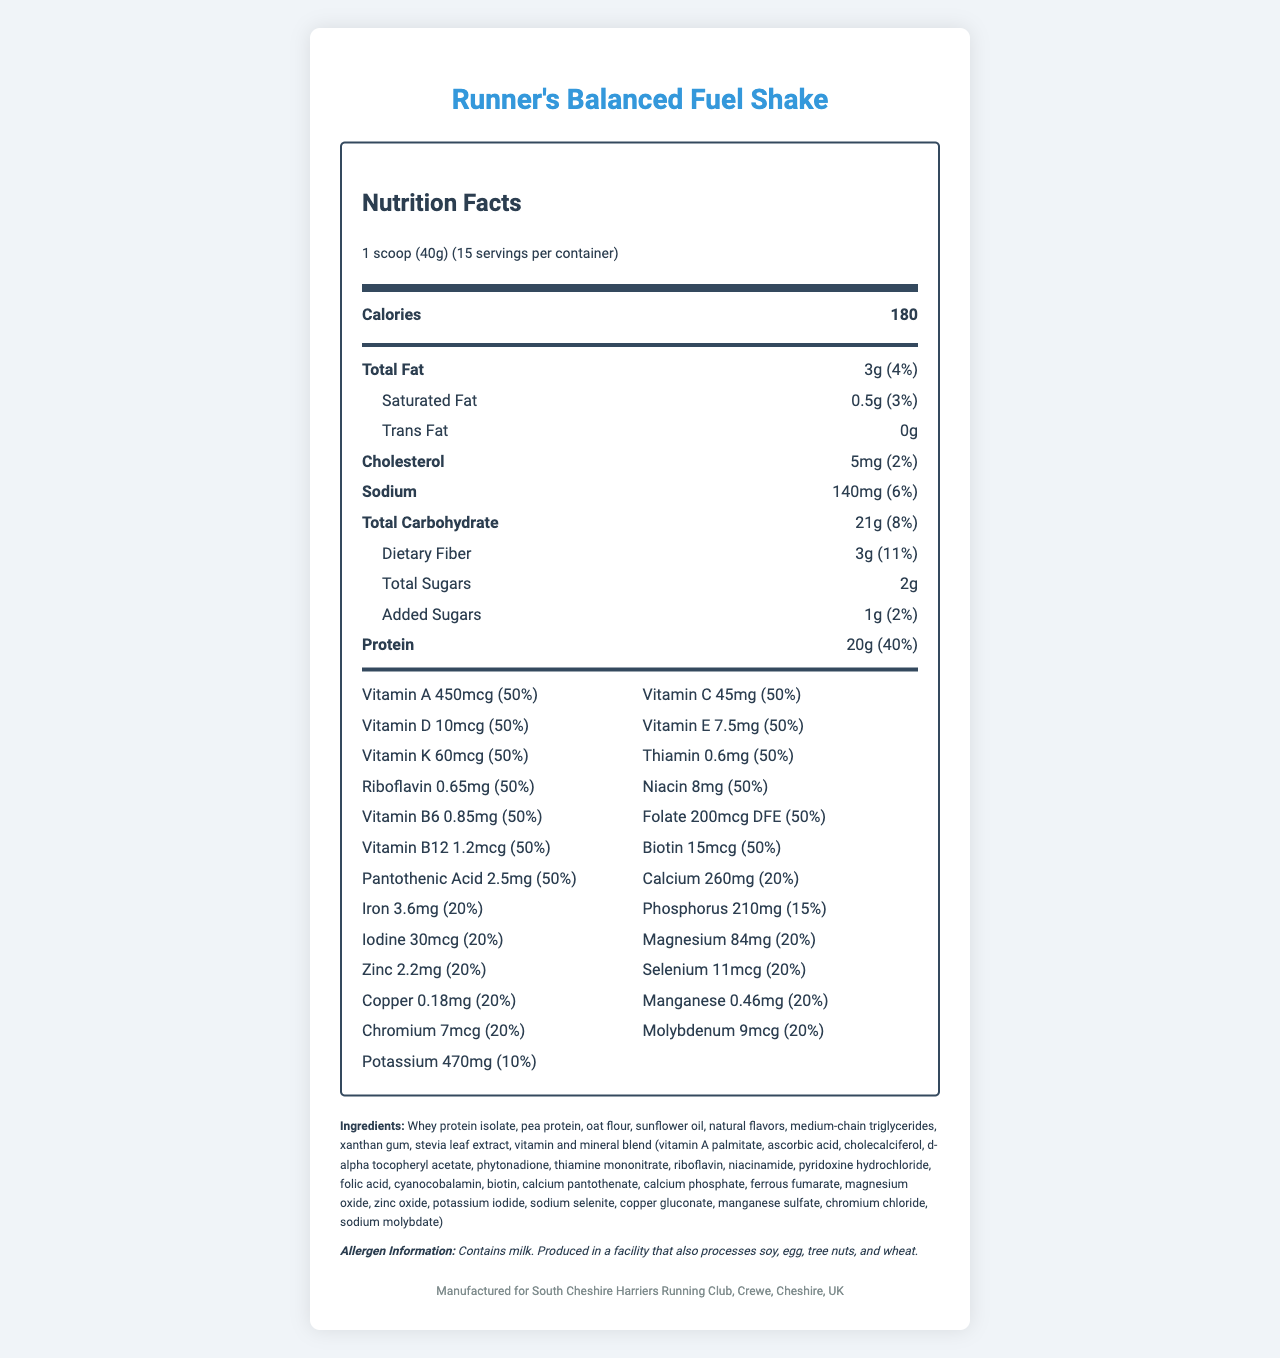what is the serving size? The document lists the serving size at the top as "1 scoop (40g)".
Answer: 1 scoop (40g) how many servings are in the container? The document states that there are 15 servings per container, visible in the serving size section.
Answer: 15 what is the total fat content in one serving? The total fat content per serving is 3g, as displayed in the nutrient information.
Answer: 3g which vitamin has a 20% daily value per serving? A. Vitamin D B. Vitamin A C. Calcium D. Vitamin B12 The daily value for Calcium per serving is 20%, while the rest have different values.
Answer: C does the product contain any sugars? The document lists total sugars as 2g and added sugars as 1g, showing the product does contain sugars.
Answer: Yes is this product suitable for someone with a milk allergy? The allergen information at the bottom clearly states that the product contains milk.
Answer: No how much protein is provided per serving? The nutrient information section lists the protein content per serving as 20g.
Answer: 20g what is the percentage daily value of dietary fiber? The document states that the dietary fiber content is 3g per serving, which corresponds to 11% of the daily value.
Answer: 11% which vitamins are at 50% daily value per serving? These vitamins are listed in the nutrition facts table with each having a daily value of 50%.
Answer: Vitamin A, Vitamin C, Vitamin D, Vitamin E, Vitamin K, Thiamin, Riboflavin, Niacin, Vitamin B6, Folate, Vitamin B12, Biotin, Pantothenic Acid how many calories does one serving contain? The calories per serving are listed as 180 in the main nutritional information section.
Answer: 180 which ingredient appears first in the list? A. Pea protein B. Whey protein isolate C. Oat flour D. Sunflower oil The first ingredient listed is whey protein isolate.
Answer: B what is the manufacturer information provided? The manufacturer information is given at the bottom of the document.
Answer: Manufactured for South Cheshire Harriers Running Club, Crewe, Cheshire, UK how much calcium does one serving provide? The document lists calcium content per serving as 260mg in the vitamins and minerals section.
Answer: 260mg what is the main source of protein in the product? The primary ingredient listed is whey protein isolate, indicating it as the main source of protein.
Answer: Whey protein isolate what is the percentage daily value of magnesium in the product? The document mentions the daily value of magnesium per serving as 20%.
Answer: 20% what flavors are used in the product? The only flavors listed in the ingredients section are "natural flavors".
Answer: Natural flavors what type of sweetener is in the product? The ingredients list mentions stevia leaf extract as the sweetener.
Answer: Stevia leaf extract is there any trans fat in the product? The document lists trans fat as 0g per serving.
Answer: No describe the document The document provides comprehensive nutrition information for a meal replacement shake, focusing on vitamins and minerals, along with other nutritional details and ingredients.
Answer: The document provides the nutrition facts label for Runner's Balanced Fuel Shake, detailing information about serving size, servings per container, calorie content, macronutrients, vitamins, minerals, ingredients, allergen information, and manufacturer details. The main emphasis is on the balance of essential vitamins and minerals that make up the meal replacement shake. which mineral in the product has the highest percentage daily value per serving? The daily value of calcium per serving is 20%, higher than any other mineral listed.
Answer: Calcium what is the main idea of the document? The document's main idea is to inform consumers about the comprehensive nutritional profile of the Runner's Balanced Fuel Shake, emphasizing its balanced vitamins and minerals.
Answer: It provides detailed nutritional information for a meal replacement shake designed for balance and nutritional completeness, highlighting its vitamins and minerals content. 